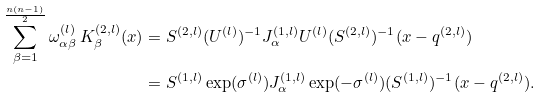<formula> <loc_0><loc_0><loc_500><loc_500>\sum _ { \beta = 1 } ^ { \frac { n ( n - 1 ) } { 2 } } \omega _ { \alpha \beta } ^ { ( l ) } \, K _ { \beta } ^ { ( 2 , l ) } ( x ) & = S ^ { ( 2 , l ) } ( U ^ { ( l ) } ) ^ { - 1 } J _ { \alpha } ^ { ( 1 , l ) } U ^ { ( l ) } ( S ^ { ( 2 , l ) } ) ^ { - 1 } ( x - q ^ { ( 2 , l ) } ) \\ & = S ^ { ( 1 , l ) } \exp ( \sigma ^ { ( l ) } ) J _ { \alpha } ^ { ( 1 , l ) } \exp ( - \sigma ^ { ( l ) } ) ( S ^ { ( 1 , l ) } ) ^ { - 1 } ( x - q ^ { ( 2 , l ) } ) .</formula> 